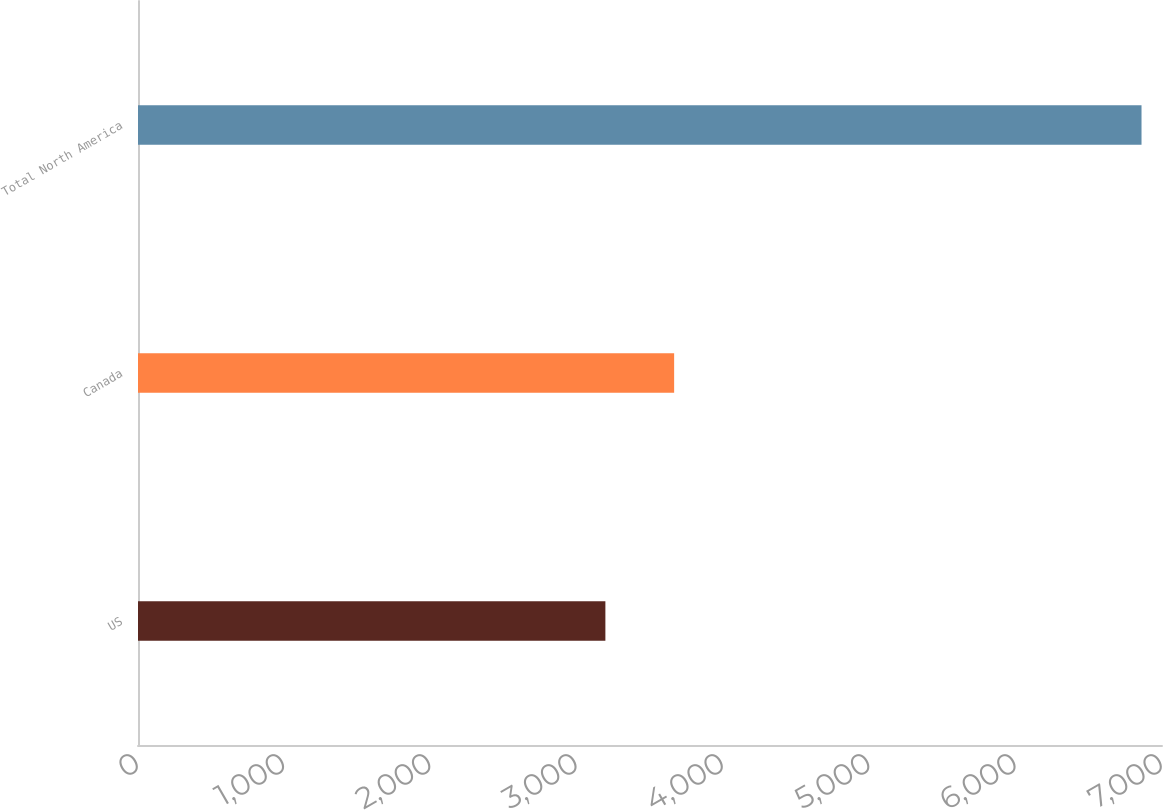Convert chart to OTSL. <chart><loc_0><loc_0><loc_500><loc_500><bar_chart><fcel>US<fcel>Canada<fcel>Total North America<nl><fcel>3195<fcel>3665<fcel>6860<nl></chart> 